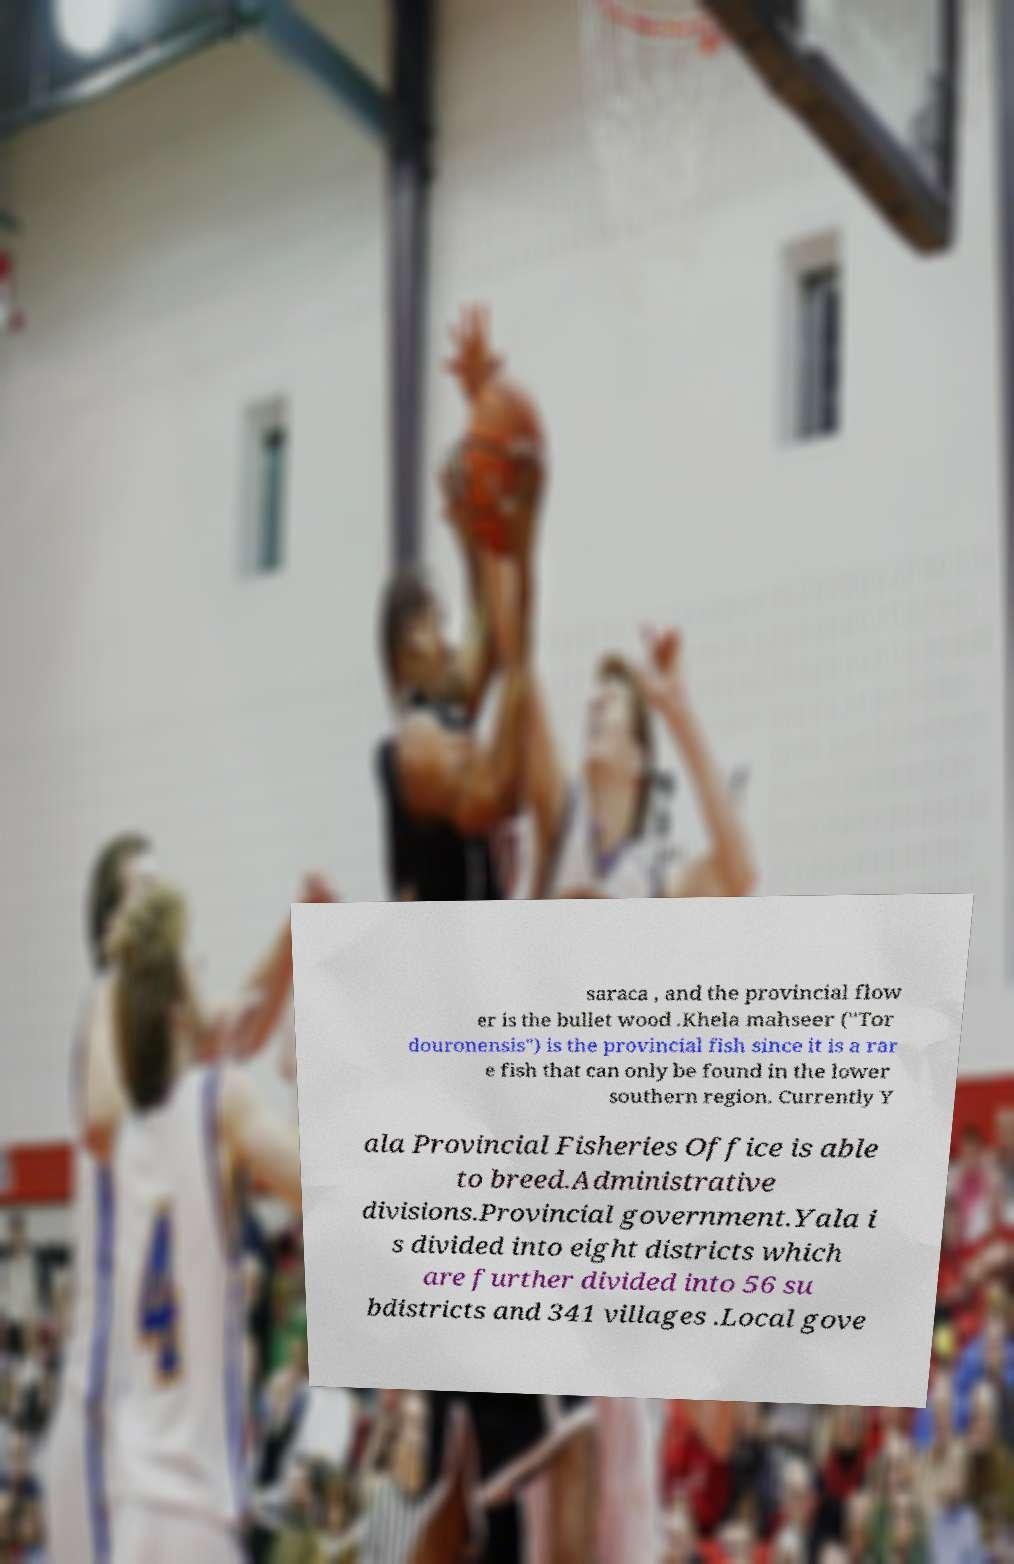I need the written content from this picture converted into text. Can you do that? saraca , and the provincial flow er is the bullet wood .Khela mahseer ("Tor douronensis") is the provincial fish since it is a rar e fish that can only be found in the lower southern region. Currently Y ala Provincial Fisheries Office is able to breed.Administrative divisions.Provincial government.Yala i s divided into eight districts which are further divided into 56 su bdistricts and 341 villages .Local gove 